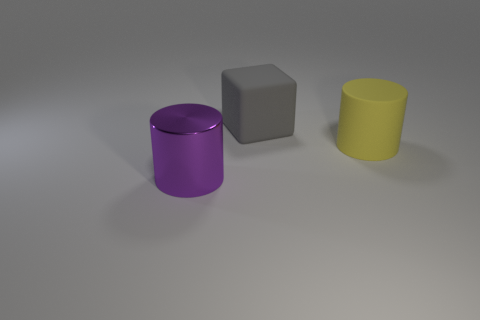The thing that is behind the large purple thing and in front of the big gray matte cube is what color?
Provide a short and direct response. Yellow. Is there a cylinder on the left side of the cylinder that is behind the large purple metallic thing in front of the big gray block?
Provide a succinct answer. Yes. There is another thing that is the same shape as the shiny object; what is its size?
Offer a very short reply. Large. Is there anything else that is the same material as the block?
Ensure brevity in your answer.  Yes. Is there a large metal thing?
Offer a very short reply. Yes. There is a matte cylinder; is its color the same as the big object to the left of the big gray matte cube?
Keep it short and to the point. No. There is a cylinder to the right of the big rubber object that is behind the big cylinder to the right of the metal thing; what is its size?
Your answer should be compact. Large. How many objects have the same color as the large cube?
Provide a short and direct response. 0. How many things are cylinders or large cylinders behind the big purple metallic cylinder?
Provide a short and direct response. 2. The metal cylinder is what color?
Your answer should be compact. Purple. 